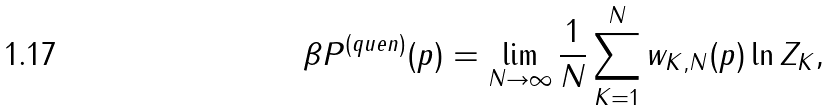<formula> <loc_0><loc_0><loc_500><loc_500>\beta P ^ { ( q u e n ) } ( p ) = \lim _ { N \to \infty } \frac { 1 } { N } \sum _ { K = 1 } ^ { N } w _ { K , N } ( p ) \ln Z _ { K } ,</formula> 